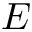<formula> <loc_0><loc_0><loc_500><loc_500>E</formula> 